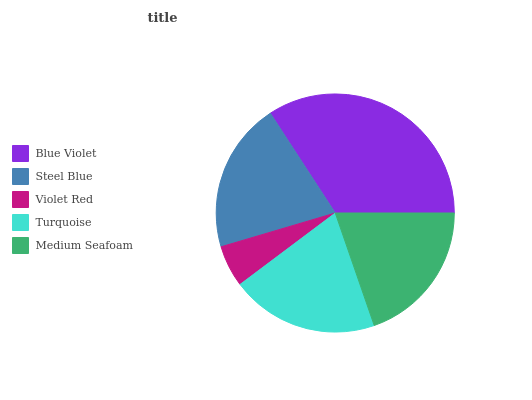Is Violet Red the minimum?
Answer yes or no. Yes. Is Blue Violet the maximum?
Answer yes or no. Yes. Is Steel Blue the minimum?
Answer yes or no. No. Is Steel Blue the maximum?
Answer yes or no. No. Is Blue Violet greater than Steel Blue?
Answer yes or no. Yes. Is Steel Blue less than Blue Violet?
Answer yes or no. Yes. Is Steel Blue greater than Blue Violet?
Answer yes or no. No. Is Blue Violet less than Steel Blue?
Answer yes or no. No. Is Turquoise the high median?
Answer yes or no. Yes. Is Turquoise the low median?
Answer yes or no. Yes. Is Blue Violet the high median?
Answer yes or no. No. Is Medium Seafoam the low median?
Answer yes or no. No. 